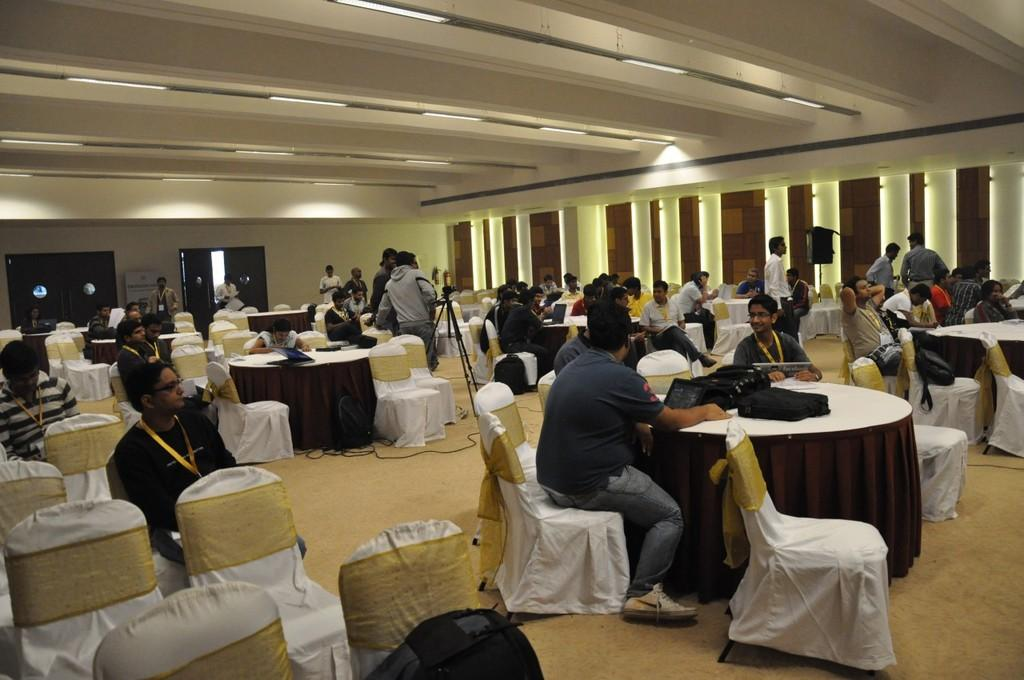Where was the image taken? The image was taken in a room. What furniture is present in the room? There are tables and chairs in the room. What is on the ceiling of the room? There are lights on the ceiling. What are the people in the image doing? The people are sitting on chairs and gathered around tables. What objects can be seen on the tables? There are bags on the tables. What color are the eggs on the table in the image? There are no eggs present in the image. What type of system is being used to control the temper of the people in the image? There is no mention of a system or temper control in the image; it simply shows people sitting around tables with bags on them. 